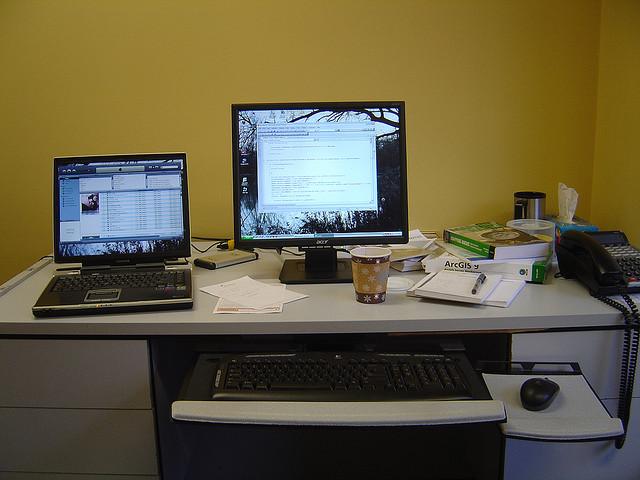Is there a telephone pictured?
Short answer required. Yes. Is there a television in the room?
Give a very brief answer. No. Which computer screen is bigger?
Give a very brief answer. Right one. Where is the paper coffee cup?
Short answer required. On desk. 